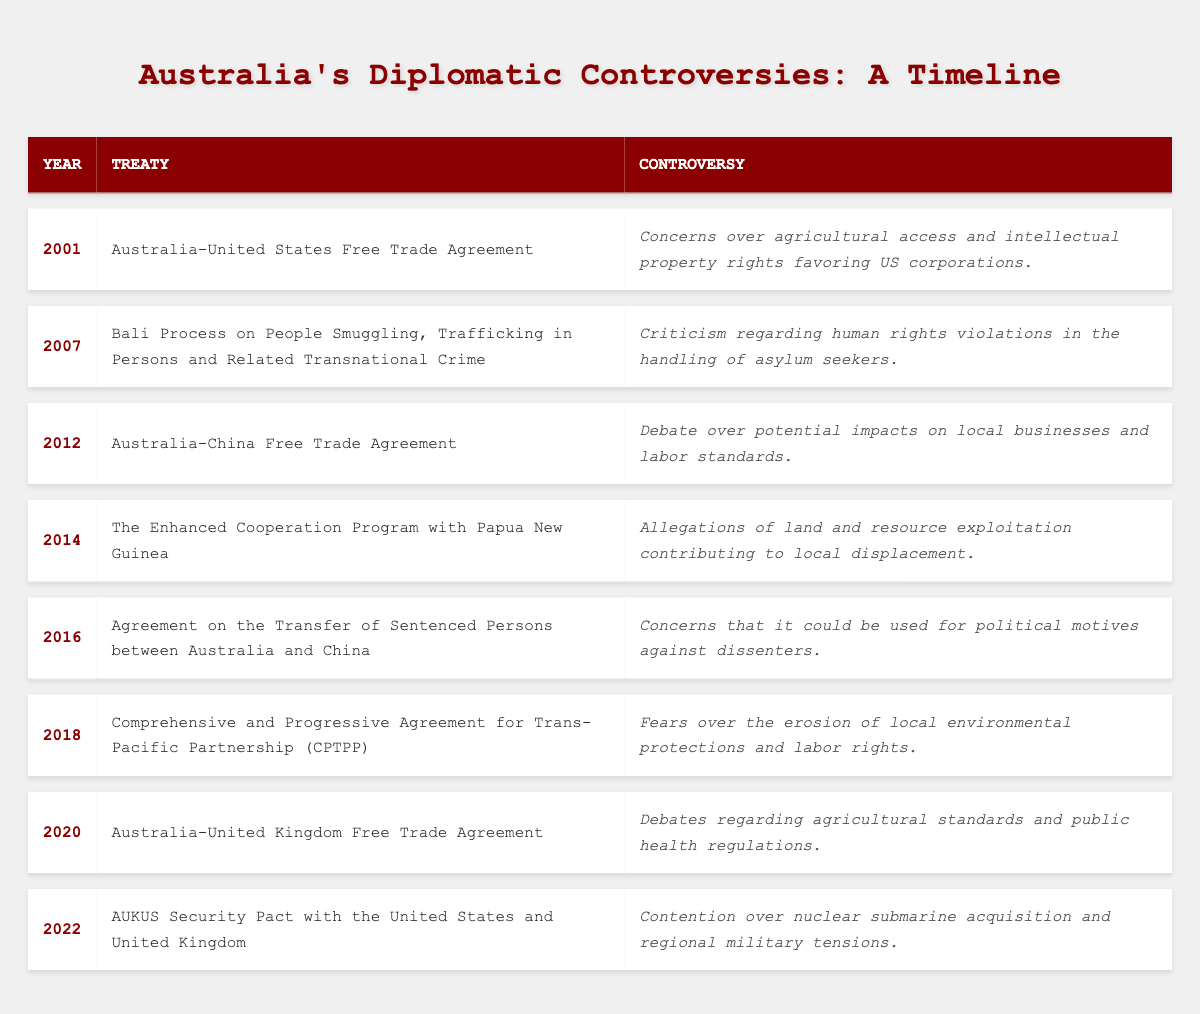What treaty was signed in 2001? The table lists the treaties along with their corresponding years. From the first row, it can be seen that the treaty signed in 2001 is the Australia-United States Free Trade Agreement.
Answer: Australia-United States Free Trade Agreement What was the main controversy associated with the AUKUS Security Pact? Referring to the last row of the table, the controversy related to the AUKUS Security Pact is contention over nuclear submarine acquisition and regional military tensions.
Answer: Contention over nuclear submarine acquisition and regional military tensions How many treaties are associated with controversies related to human rights? By examining the table, we identify that there are two treaties with controversies specifically mentioning human rights: the Bali Process in 2007 and the Agreement on the Transfer of Sentenced Persons in 2016. Therefore, the total number is two.
Answer: 2 Are there any treaties signed in the years 2012 and 2020? Checking the table, it can be confirmed that there is an entry for each of these years. In 2012, the treaty is the Australia-China Free Trade Agreement, and in 2020, it is the Australia-United Kingdom Free Trade Agreement. Therefore, the answer is yes.
Answer: Yes Which treaty had controversy related to agricultural access? Looking through the table, the Australia-United States Free Trade Agreement signed in 2001 has a controversy concerning agricultural access and intellectual property rights favoring US corporations.
Answer: Australia-United States Free Trade Agreement 